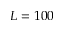Convert formula to latex. <formula><loc_0><loc_0><loc_500><loc_500>L = 1 0 0</formula> 